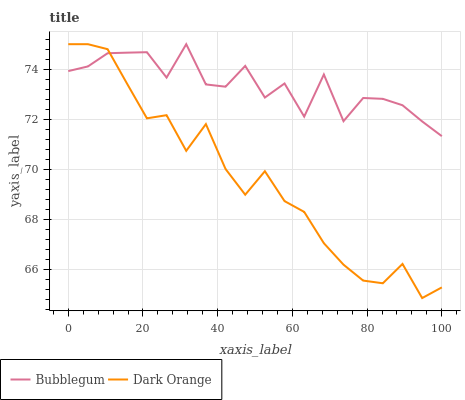Does Bubblegum have the minimum area under the curve?
Answer yes or no. No. Is Bubblegum the smoothest?
Answer yes or no. No. Does Bubblegum have the lowest value?
Answer yes or no. No. 